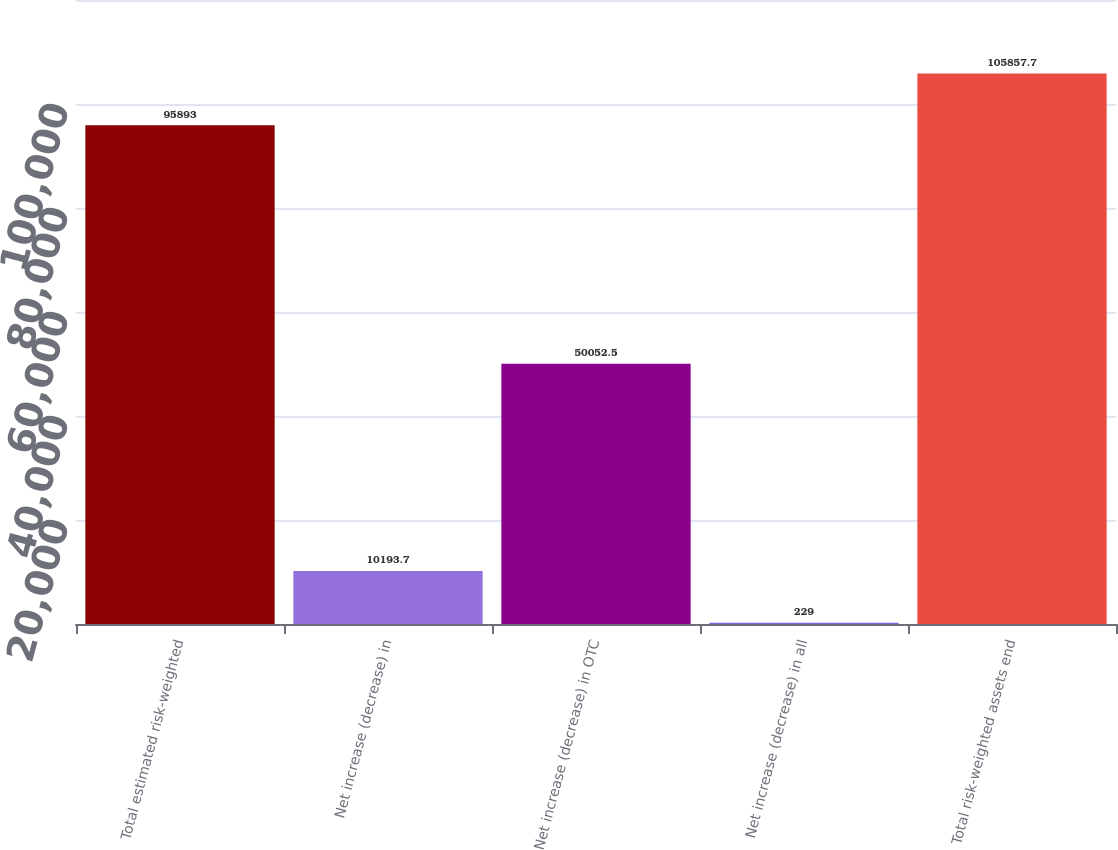<chart> <loc_0><loc_0><loc_500><loc_500><bar_chart><fcel>Total estimated risk-weighted<fcel>Net increase (decrease) in<fcel>Net increase (decrease) in OTC<fcel>Net increase (decrease) in all<fcel>Total risk-weighted assets end<nl><fcel>95893<fcel>10193.7<fcel>50052.5<fcel>229<fcel>105858<nl></chart> 